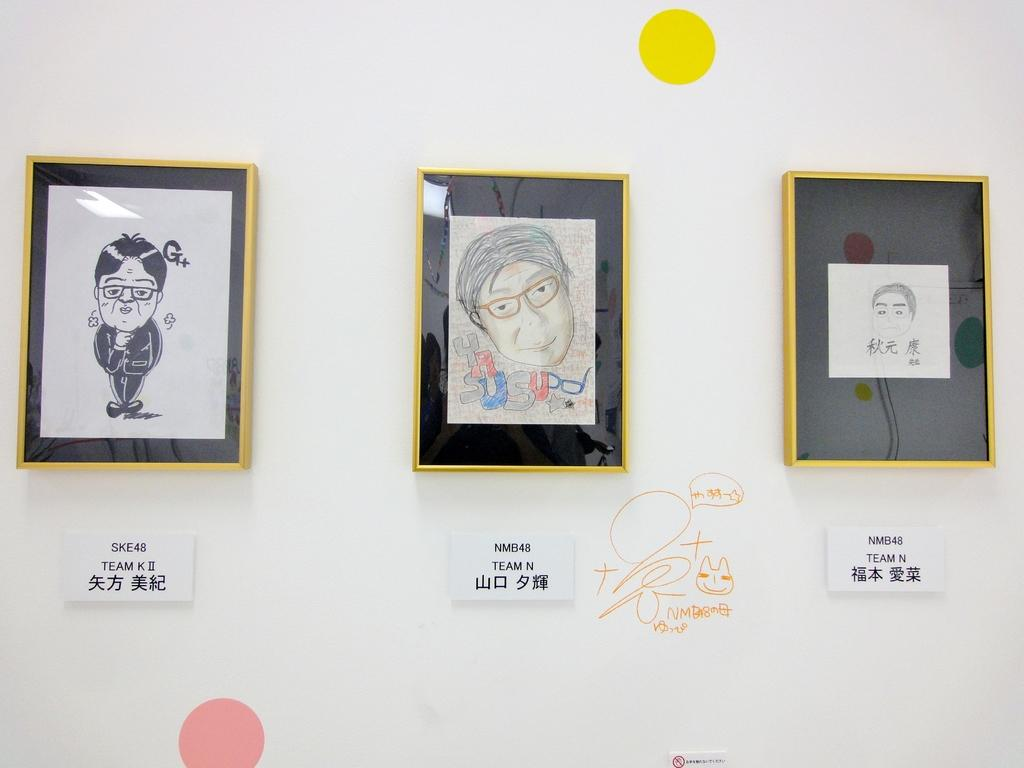What can be seen on the wall in the image? There are photo frames on the wall, as well as posts with images and text. What is written on the wall? There is text on the wall. How many toes are visible in the image? There are no toes visible in the image. What color are the eyes of the person in the image? There is no person present in the image, so their eye color cannot be determined. 